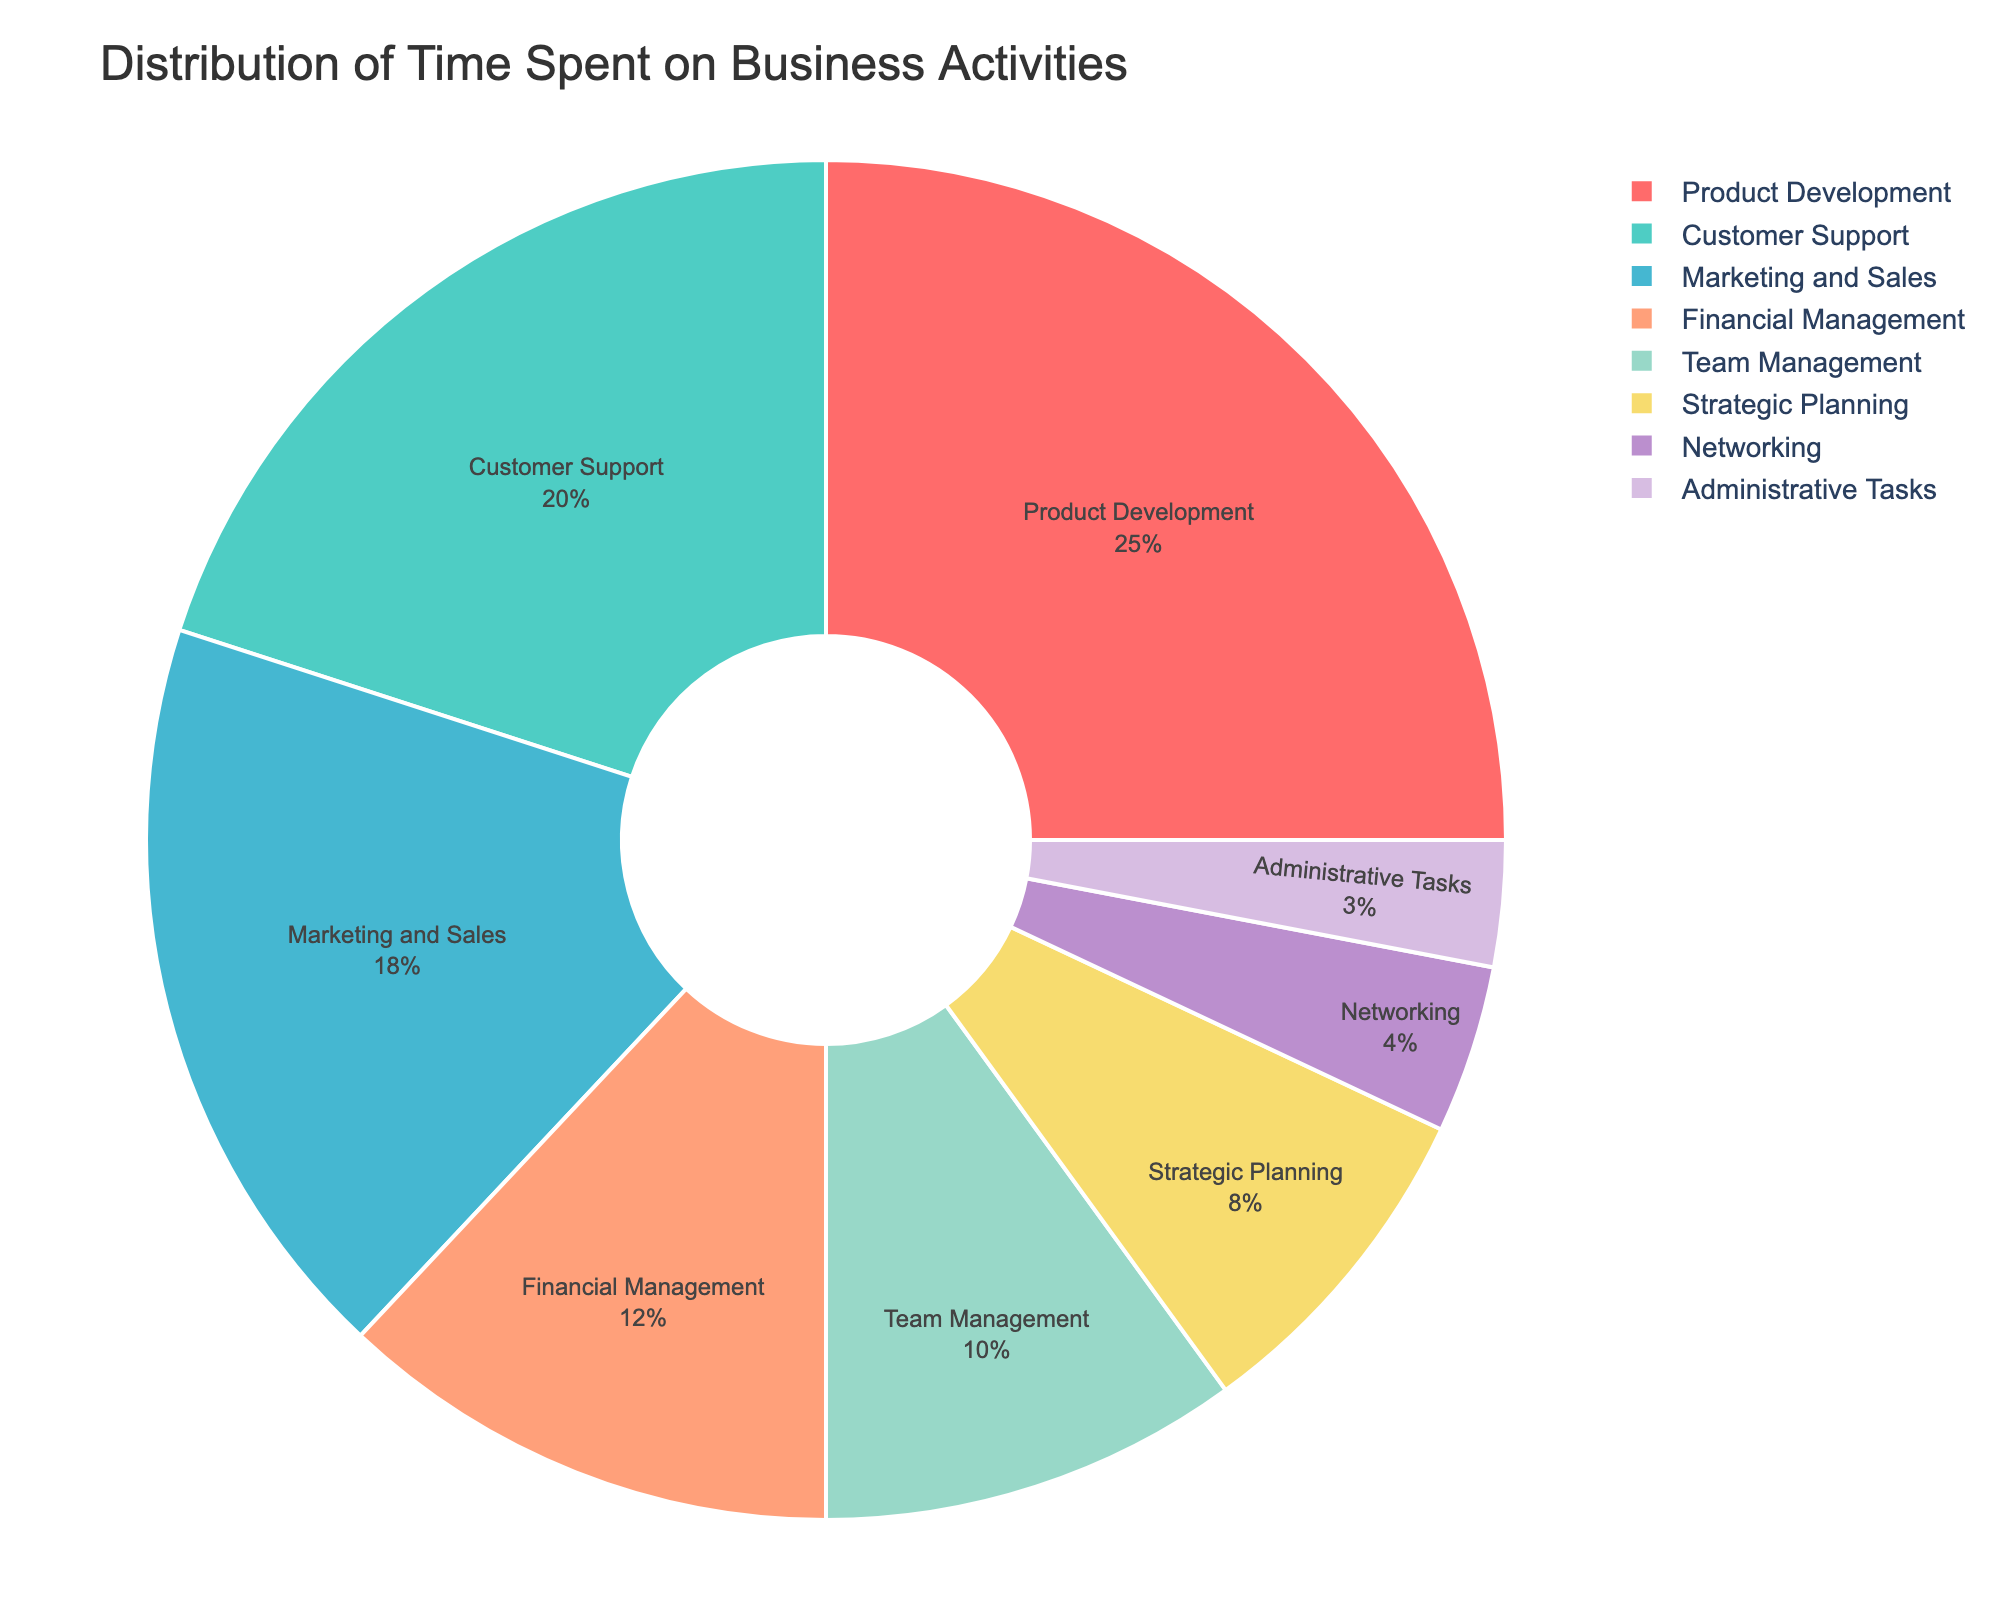What's the largest activity slice by percentage in the pie chart? The pie chart presents various activities with their respective percentages. By observing the slices, we see that the largest percentage is associated with Product Development at 25%.
Answer: Product Development Which activity takes up less than 5% of the time in the pie chart? The pie chart shows each activity's percentage. By scanning the slices, we can identify that Networking (4%) and Administrative Tasks (3%) both take up less than 5% of the time.
Answer: Networking and Administrative Tasks How much more time is spent on Marketing and Sales compared to Administrative Tasks? From the pie chart, Marketing and Sales occupy 18% and Administrative Tasks occupy 3%. To find the difference, subtract 3% from 18%, which equals 15%.
Answer: 15% Does Financial Management or Team Management take up more time? Comparing the slices, Financial Management has 12% while Team Management has 10%. So, Financial Management takes up more time.
Answer: Financial Management What is the percentage of time spent on activities related to managing the business (Financial Management, Team Management, and Administrative Tasks)? Summing up the percentages: Financial Management (12%), Team Management (10%), and Administrative Tasks (3%) total 12% + 10% + 3% = 25%.
Answer: 25% Which activity is represented by the green slice in the pie chart? The custom color palette assigns specific colors to each section. The green slice corresponds to Customer Support, which takes up 20% of the pie chart.
Answer: Customer Support Are there any activities that together occupy exactly as much time as Product Development? Product Development is 25%. By checking other slices: Customer Support (20%) + Administrative Tasks (3%) adds only to 23%. Strategic Planning (8%) + Administrative Tasks (3%) is 11%. Financial Management (12%) + Team Management (10%) = 22%. Marketing and Sales (18%) + Networking (4%) results in 22%. None combine with another to precisely match 25%.
Answer: No What's the combined percentage of time allocated to product and customer-facing roles (Product Development, Customer Support, Marketing and Sales)? Adding the respective percentages: Product Development (25%), Customer Support (20%), Marketing and Sales (18%). Sum: 25% + 20% + 18% = 63%.
Answer: 63% How many activities take up less than or equal to 10% of the time each? Observing the pie chart, Networking (4%), Administrative Tasks (3%), Strategic Planning (8%), and Team Management (10%) are each <= 10%. Counting these activities, we have 4.
Answer: 4 